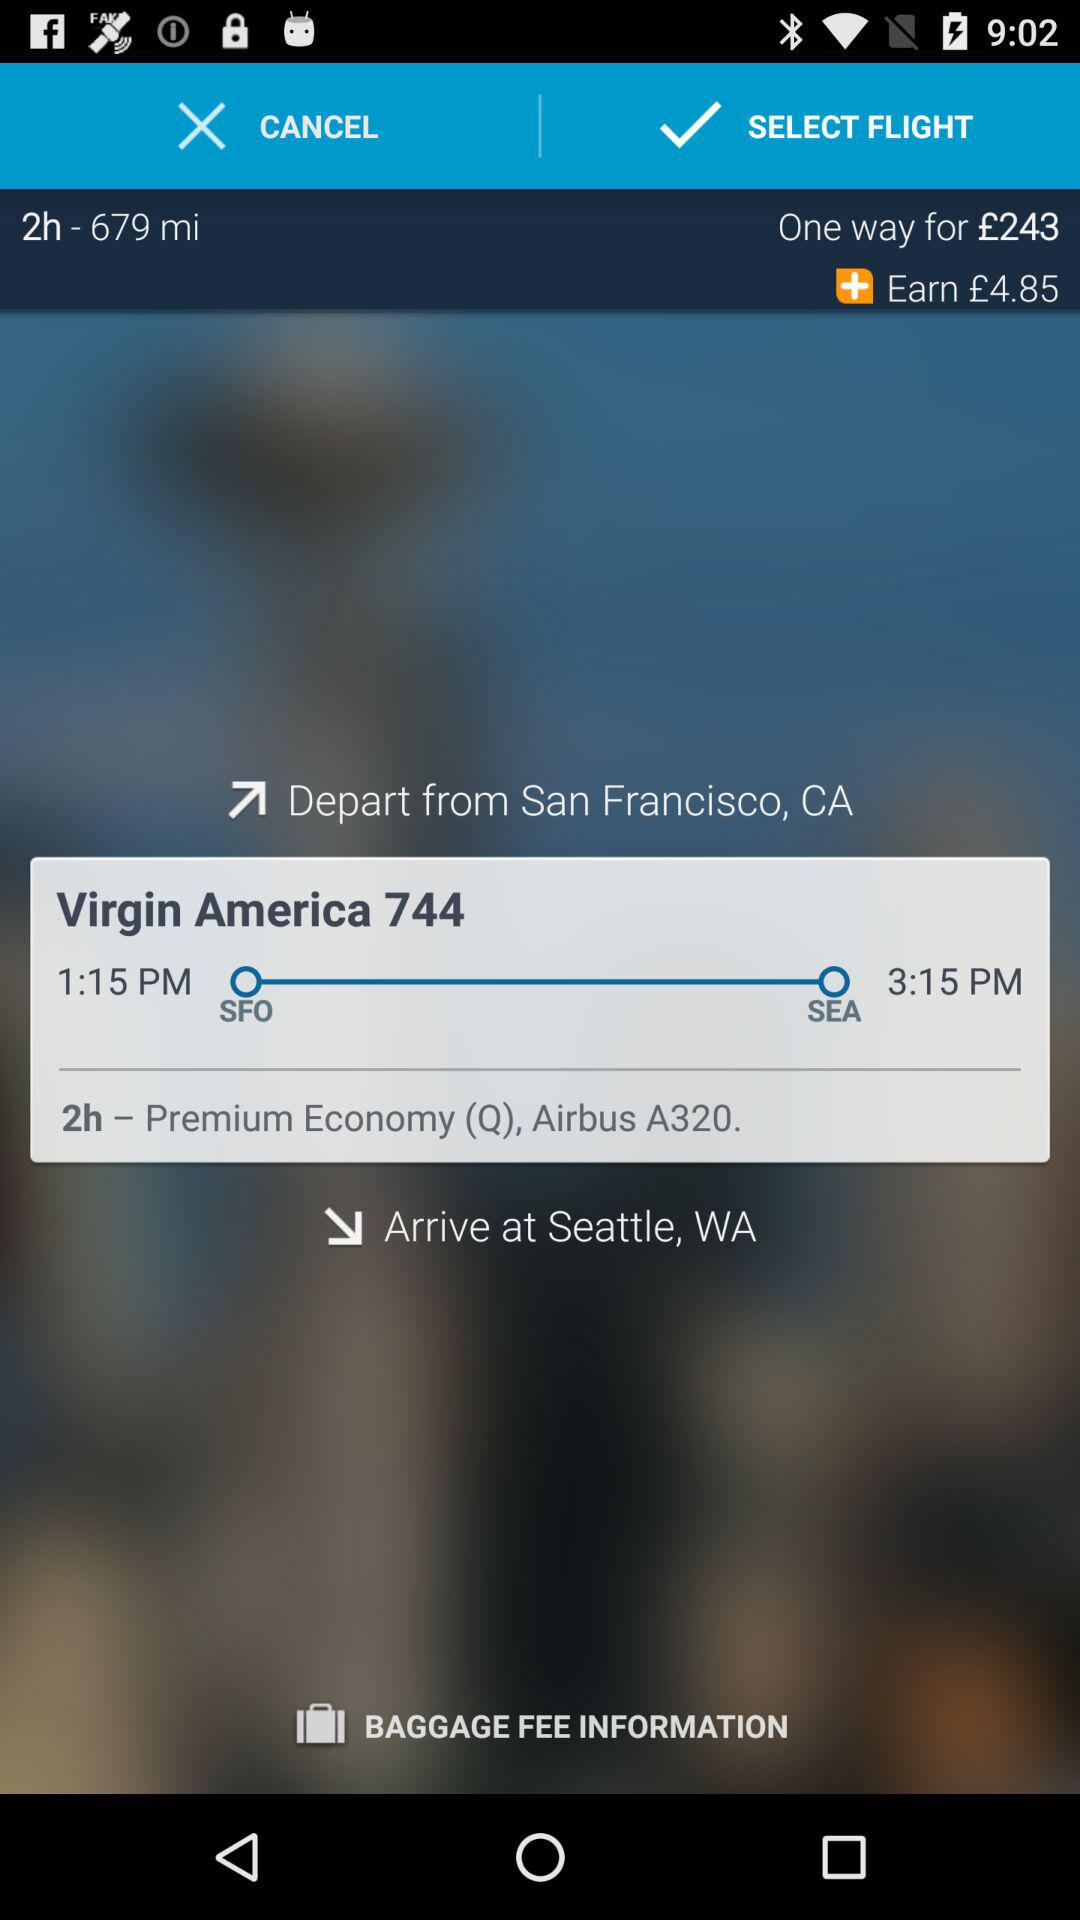What is the departure location? The departure location is San Francisco, CA. 